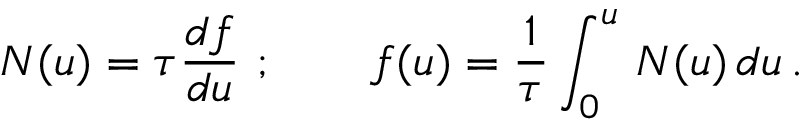Convert formula to latex. <formula><loc_0><loc_0><loc_500><loc_500>N ( u ) = \tau { \frac { d f } { d u } } \ ; \quad f ( u ) = { \frac { 1 } { \tau } } \int _ { 0 } ^ { u } \, N ( u ) \, d u \, .</formula> 